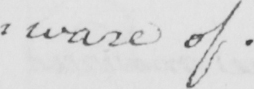What text is written in this handwritten line? : ware of . 